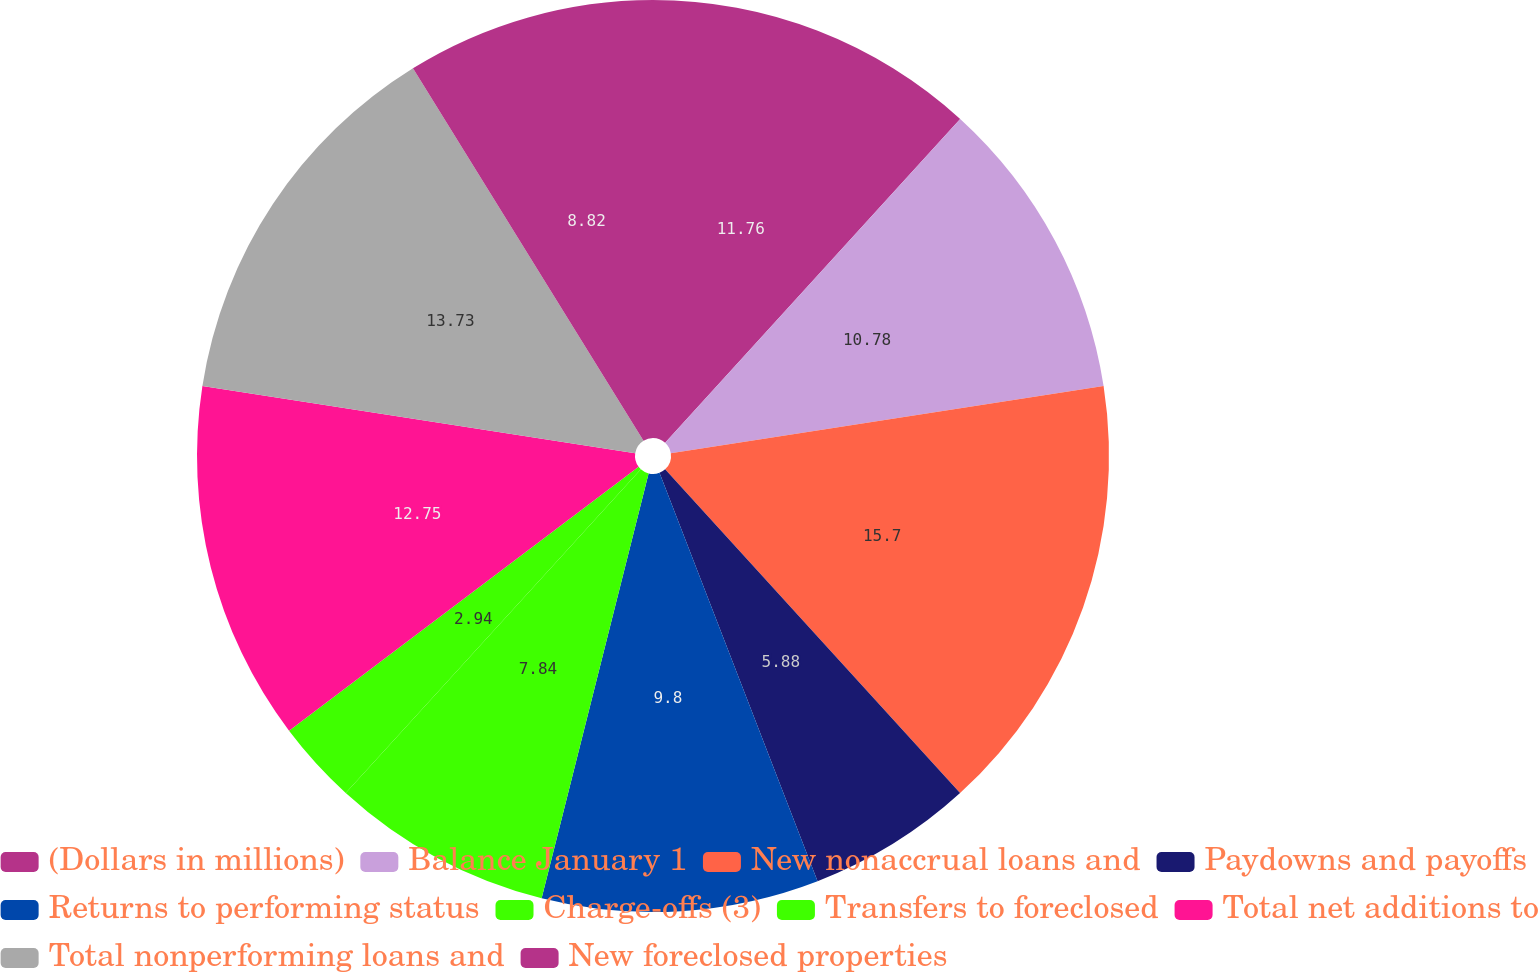Convert chart. <chart><loc_0><loc_0><loc_500><loc_500><pie_chart><fcel>(Dollars in millions)<fcel>Balance January 1<fcel>New nonaccrual loans and<fcel>Paydowns and payoffs<fcel>Returns to performing status<fcel>Charge-offs (3)<fcel>Transfers to foreclosed<fcel>Total net additions to<fcel>Total nonperforming loans and<fcel>New foreclosed properties<nl><fcel>11.76%<fcel>10.78%<fcel>15.69%<fcel>5.88%<fcel>9.8%<fcel>7.84%<fcel>2.94%<fcel>12.74%<fcel>13.72%<fcel>8.82%<nl></chart> 